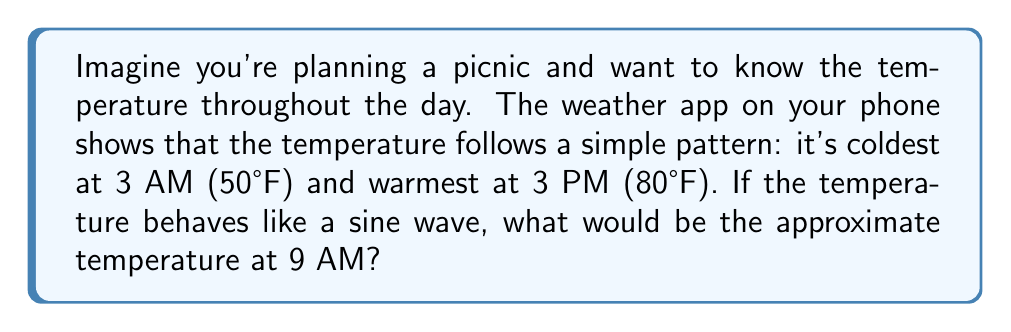Can you answer this question? Let's break this down into simple steps:

1. We can model the temperature using a sine function of the form:
   $$T(t) = A \sin(\omega t - \phi) + M$$
   where $T$ is temperature, $t$ is time, $A$ is amplitude, $\omega$ is frequency, $\phi$ is phase shift, and $M$ is the midline.

2. Find the midline (average temperature):
   $M = \frac{50°F + 80°F}{2} = 65°F$

3. Calculate the amplitude:
   $A = \frac{80°F - 50°F}{2} = 15°F$

4. The period of the temperature cycle is 24 hours, so:
   $\omega = \frac{2\pi}{24} = \frac{\pi}{12}$

5. The coldest time (3 AM) corresponds to $-\frac{\pi}{2}$ in the sine function, so:
   $\phi = \frac{3\pi}{12} = \frac{\pi}{4}$

6. Our function is now:
   $$T(t) = 15 \sin(\frac{\pi}{12}t - \frac{\pi}{4}) + 65$$

7. At 9 AM, $t = 9$. Let's plug this in:
   $$T(9) = 15 \sin(\frac{\pi}{12} \cdot 9 - \frac{\pi}{4}) + 65$$
   $$= 15 \sin(\frac{3\pi}{4} - \frac{\pi}{4}) + 65$$
   $$= 15 \sin(\frac{\pi}{2}) + 65$$
   $$= 15 \cdot 1 + 65 = 80°F$$

Therefore, the temperature at 9 AM would be approximately 80°F.
Answer: 80°F 